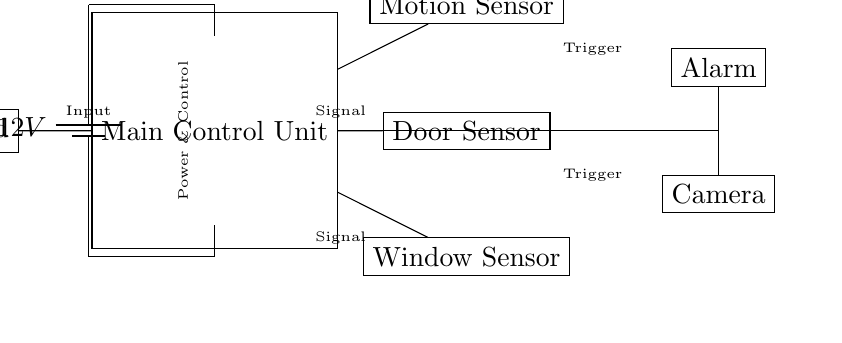What is the voltage of the power supply? The circuit shows a battery labeled with a voltage of 12 volts, indicating this is the potential difference provided to the circuit.
Answer: 12 volts What component is used for input? The diagram shows a keypad connected to the main control unit, functioning as an input device for the security system.
Answer: Keypad How many sensors are shown in the circuit? The diagram features three sensors: a motion sensor, a door sensor, and a window sensor, all of which connect to the main control unit.
Answer: Three What is the function of the main control unit? The main control unit is responsible for processing signals from the sensors and sending triggers to the alarm and camera, effectively being the brain of the security system.
Answer: Processing signals What do the arrows connecting the components represent? The arrows represent signal connections between the main control unit and the sensors, as well as the connections to the alarm and camera, indicating the flow of information.
Answer: Signal connections Which component receives a trigger from the main control unit? The diagram indicates that both the alarm and the camera receive triggers from the main control unit, as shown by the connections leading from the unit.
Answer: Alarm and Camera 